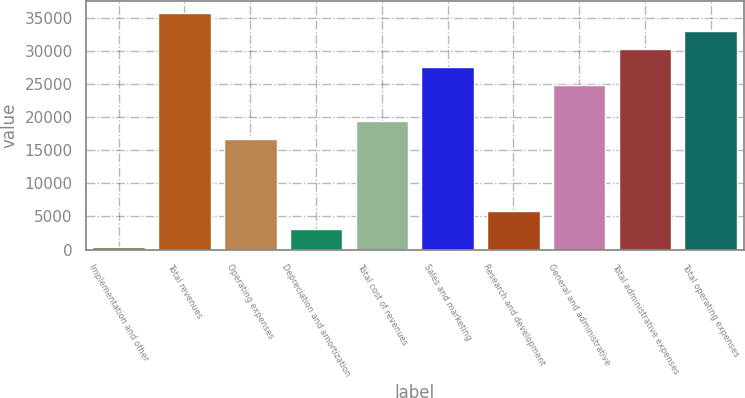Convert chart. <chart><loc_0><loc_0><loc_500><loc_500><bar_chart><fcel>Implementation and other<fcel>Total revenues<fcel>Operating expenses<fcel>Depreciation and amortization<fcel>Total cost of revenues<fcel>Sales and marketing<fcel>Research and development<fcel>General and administrative<fcel>Total administrative expenses<fcel>Total operating expenses<nl><fcel>373<fcel>35738.2<fcel>16695.4<fcel>3093.4<fcel>19415.8<fcel>27577<fcel>5813.8<fcel>24856.6<fcel>30297.4<fcel>33017.8<nl></chart> 